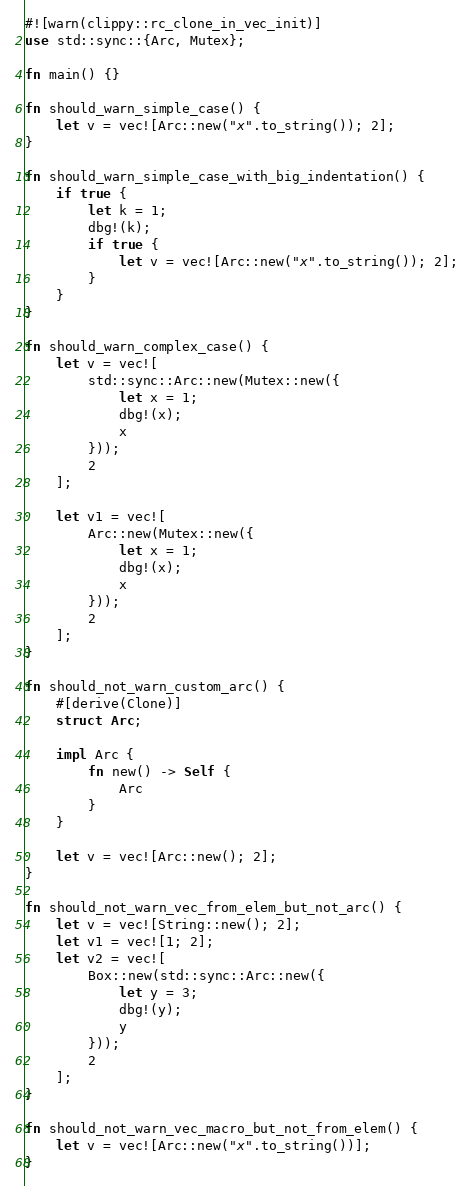Convert code to text. <code><loc_0><loc_0><loc_500><loc_500><_Rust_>#![warn(clippy::rc_clone_in_vec_init)]
use std::sync::{Arc, Mutex};

fn main() {}

fn should_warn_simple_case() {
    let v = vec![Arc::new("x".to_string()); 2];
}

fn should_warn_simple_case_with_big_indentation() {
    if true {
        let k = 1;
        dbg!(k);
        if true {
            let v = vec![Arc::new("x".to_string()); 2];
        }
    }
}

fn should_warn_complex_case() {
    let v = vec![
        std::sync::Arc::new(Mutex::new({
            let x = 1;
            dbg!(x);
            x
        }));
        2
    ];

    let v1 = vec![
        Arc::new(Mutex::new({
            let x = 1;
            dbg!(x);
            x
        }));
        2
    ];
}

fn should_not_warn_custom_arc() {
    #[derive(Clone)]
    struct Arc;

    impl Arc {
        fn new() -> Self {
            Arc
        }
    }

    let v = vec![Arc::new(); 2];
}

fn should_not_warn_vec_from_elem_but_not_arc() {
    let v = vec![String::new(); 2];
    let v1 = vec![1; 2];
    let v2 = vec![
        Box::new(std::sync::Arc::new({
            let y = 3;
            dbg!(y);
            y
        }));
        2
    ];
}

fn should_not_warn_vec_macro_but_not_from_elem() {
    let v = vec![Arc::new("x".to_string())];
}
</code> 